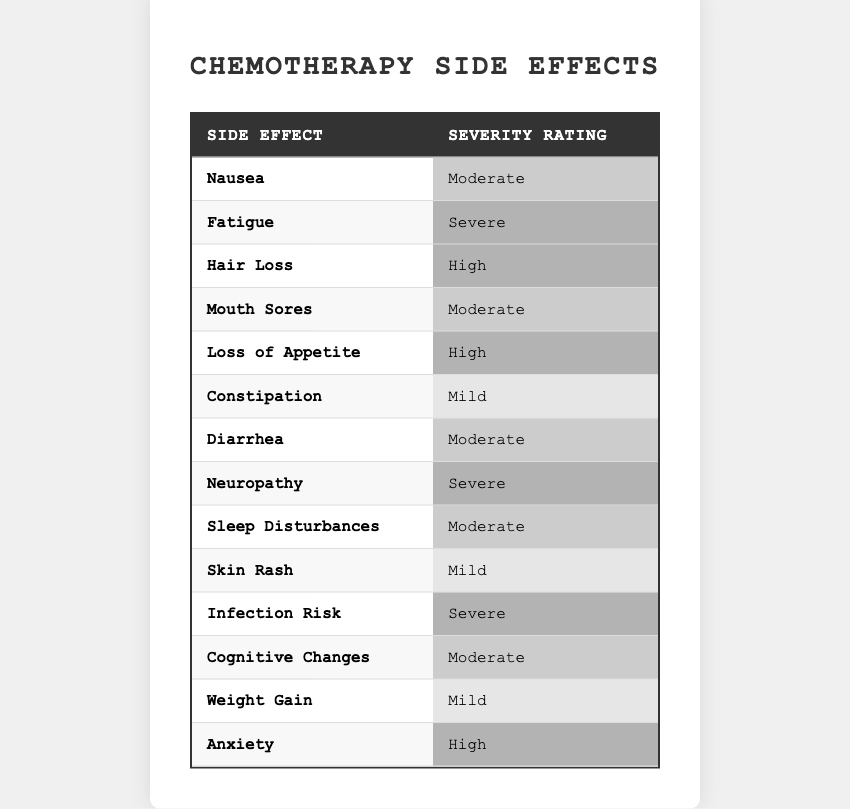What is the severity rating for Nausea? The table shows that the severity rating for Nausea is listed under the relevant row, which indicates that it is rated as Moderate.
Answer: Moderate How many side effects are rated as Severe? By counting the rows in the table where the Severity Rating is Severe, we find that there are three instances: Fatigue, Neuropathy, and Infection Risk.
Answer: 3 Which side effect has the highest severity rating? The table lists Hair Loss, Loss of Appetite, and Anxiety as having a High severity rating, but since "Severe" is a higher classification, Fatigue, Neuropathy, and Infection Risk are the highest-rated side effects.
Answer: Fatigue, Neuropathy, Infection Risk Are there more side effects with a Moderate rating or a Mild rating? The table shows five side effects rated Moderate (Nausea, Mouth Sores, Diarrhea, Sleep Disturbances, Cognitive Changes) and three rated Mild (Constipation, Skin Rash, Weight Gain). Comparing these counts reveals that there are more Moderate ratings.
Answer: More Moderate What is the total number of side effects listed in the table? The table shows a total of 14 different side effects, each on its own row. By counting the rows, we confirm it sums up to 14.
Answer: 14 Is Anxiety the only side effect rated as High? The data indicates two side effects rated High: Loss of Appetite and Anxiety. Therefore, Anxiety is not the only one.
Answer: No What is the average severity rating of the side effects? To average the severity ratings, we need to assign numerical values: Mild (1), Moderate (2), High (3), Severe (4). Summing the ratings, (1*3 + 2*5 + 3*3 + 4*3) / 14 gives us an average rating of approximately 2.14, which corresponds to Moderate.
Answer: Moderate Which side effect has a severity rating of Mild? The table lists Constipation, Skin Rash, and Weight Gain as side effects with a Mild severity rating. Any of these can be mentioned.
Answer: Constipation (or Skin Rash, or Weight Gain) Which side effects are rated as High severity? The table shows that Hair Loss and Loss of Appetite are the side effects rated as High severity.
Answer: Hair Loss, Loss of Appetite How many side effects are classified as either High or Severe? Counting those rated High (2: Hair Loss, Loss of Appetite) and Severe (3: Fatigue, Neuropathy, Infection Risk), we find a total of 5 side effects classified in these categories.
Answer: 5 